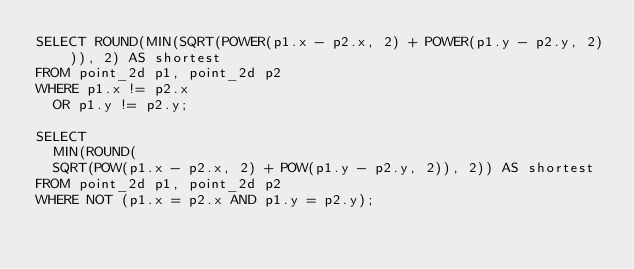Convert code to text. <code><loc_0><loc_0><loc_500><loc_500><_SQL_>SELECT ROUND(MIN(SQRT(POWER(p1.x - p2.x, 2) + POWER(p1.y - p2.y, 2))), 2) AS shortest 
FROM point_2d p1, point_2d p2
WHERE p1.x != p2.x
  OR p1.y != p2.y;

SELECT
  MIN(ROUND(
  SQRT(POW(p1.x - p2.x, 2) + POW(p1.y - p2.y, 2)), 2)) AS shortest
FROM point_2d p1, point_2d p2 
WHERE NOT (p1.x = p2.x AND p1.y = p2.y);</code> 